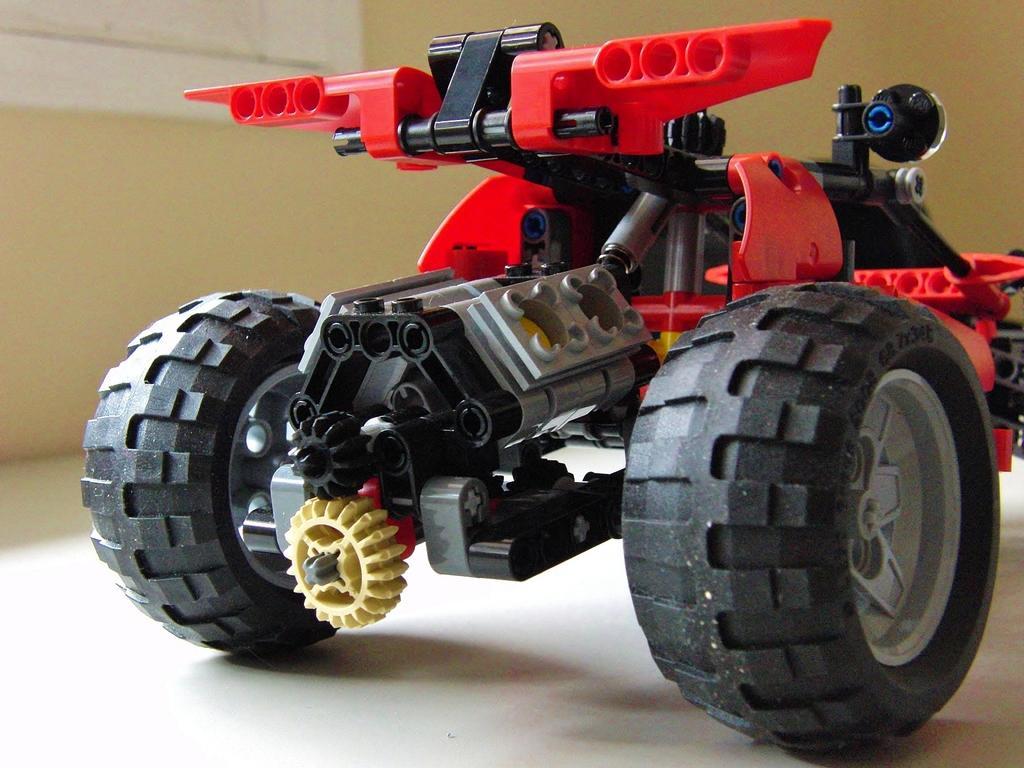In one or two sentences, can you explain what this image depicts? In the center of the image, we can see a toy vehicle on the floor and in the background, there is a wall. 